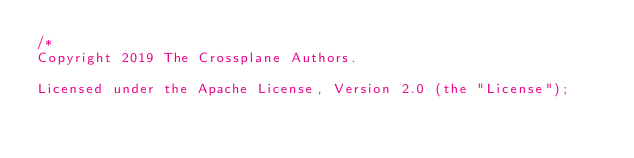Convert code to text. <code><loc_0><loc_0><loc_500><loc_500><_Go_>/*
Copyright 2019 The Crossplane Authors.

Licensed under the Apache License, Version 2.0 (the "License");</code> 